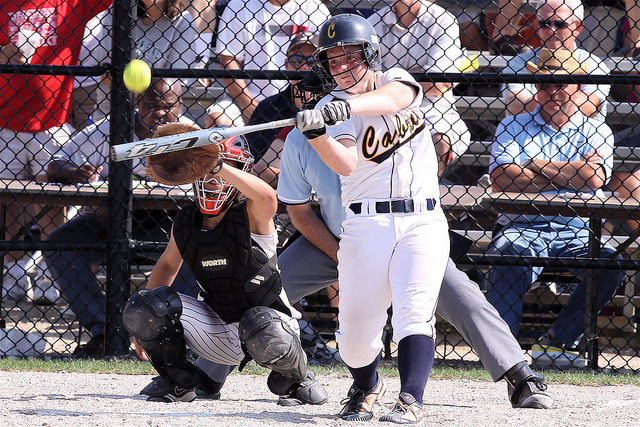Can you see any other equipment or items on the field other than the players? Apart from the players themselves, there is a bat being held by the batter and a ball in motion. The catcher is equipped with protective gear including a mask, chest pad, and leg guards. Additionally, there is a chain-link fence separating the spectators from the field. 